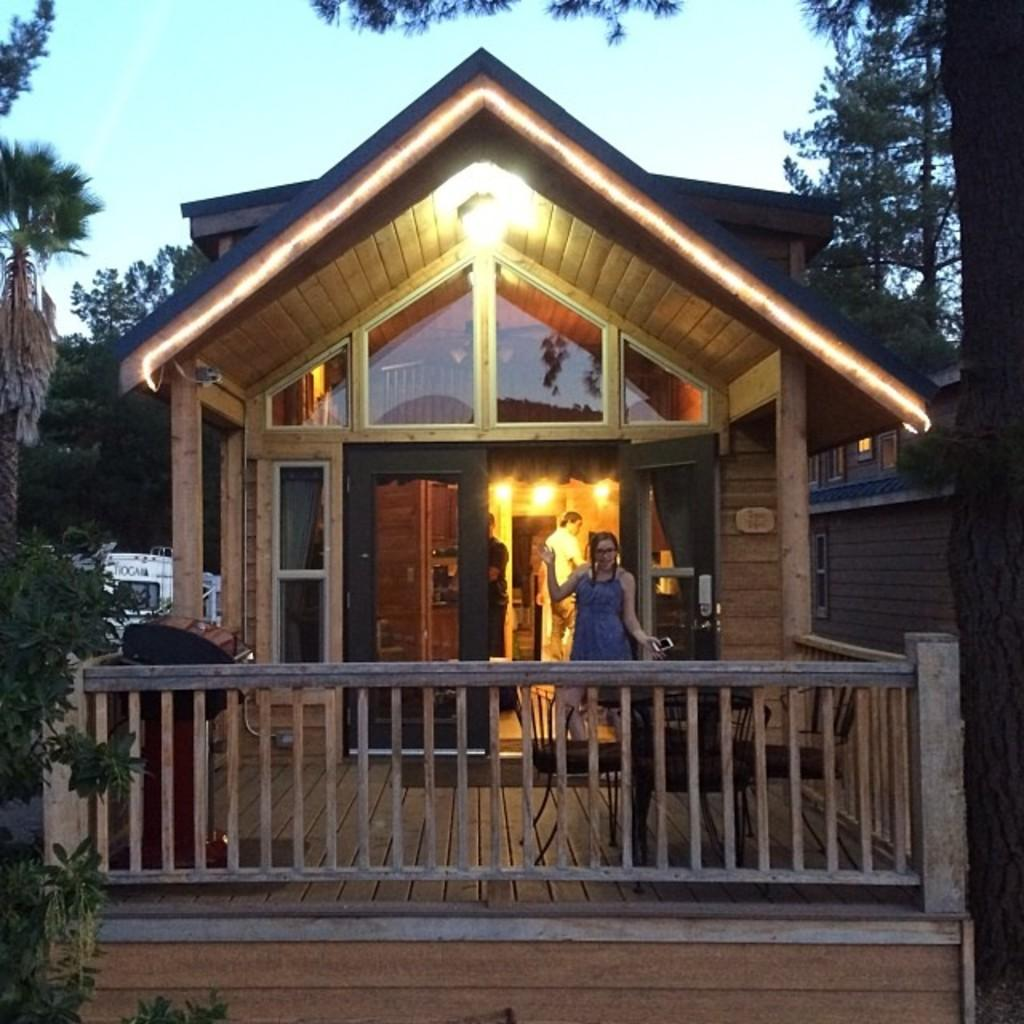What type of structures can be seen in the image? There are sheds in the image. Are there any people present in the image? Yes, there are people in the image. What feature can be seen on the sheds or other structures? Railings are visible in the image. What can be used for illumination in the image? Lights are present in the image. What type of natural elements are in the image? Trees are in the image. What is the lady in the image holding? The lady is holding a mobile in the image. What can be seen in the background of the image? A vehicle is visible in the background of the image. What is visible at the top of the image? The sky is visible at the top of the image. What type of substance is leaking from the sheds in the image? There is no indication of any substance leaking from the sheds in the image. Are there any corn plants visible in the image? There is no mention of corn plants in the image; it features sheds, people, railings, lights, trees, a lady holding a mobile, a vehicle in the background, and the sky. 